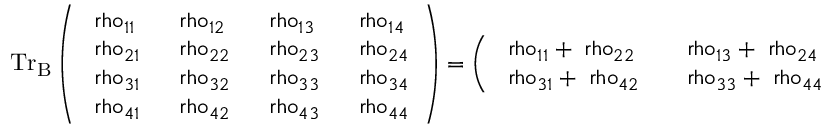Convert formula to latex. <formula><loc_0><loc_0><loc_500><loc_500>{ T r } _ { B } \left ( \begin{array} { l l l l } { \ r h o _ { 1 1 } } & { \ r h o _ { 1 2 } } & { \ r h o _ { 1 3 } } & { \ r h o _ { 1 4 } } \\ { \ r h o _ { 2 1 } } & { \ r h o _ { 2 2 } } & { \ r h o _ { 2 3 } } & { \ r h o _ { 2 4 } } \\ { \ r h o _ { 3 1 } } & { \ r h o _ { 3 2 } } & { \ r h o _ { 3 3 } } & { \ r h o _ { 3 4 } } \\ { \ r h o _ { 4 1 } } & { \ r h o _ { 4 2 } } & { \ r h o _ { 4 3 } } & { \ r h o _ { 4 4 } } \end{array} \right ) = \left ( \begin{array} { l l } { \ r h o _ { 1 1 } + \ r h o _ { 2 2 } } & { \ r h o _ { 1 3 } + \ r h o _ { 2 4 } } \\ { \ r h o _ { 3 1 } + \ r h o _ { 4 2 } } & { \ r h o _ { 3 3 } + \ r h o _ { 4 4 } } \end{array} \right )</formula> 